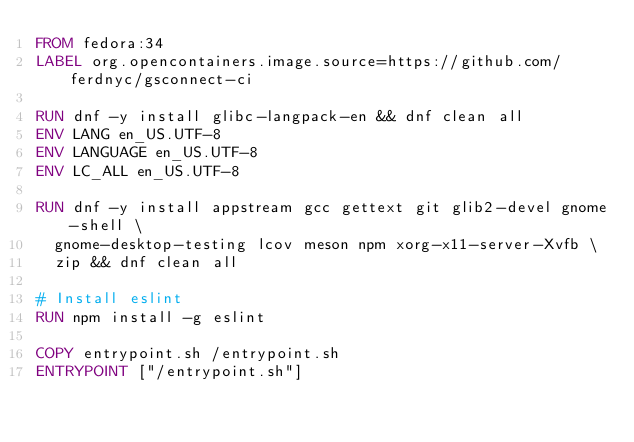<code> <loc_0><loc_0><loc_500><loc_500><_Dockerfile_>FROM fedora:34
LABEL org.opencontainers.image.source=https://github.com/ferdnyc/gsconnect-ci

RUN dnf -y install glibc-langpack-en && dnf clean all
ENV LANG en_US.UTF-8
ENV LANGUAGE en_US.UTF-8
ENV LC_ALL en_US.UTF-8

RUN dnf -y install appstream gcc gettext git glib2-devel gnome-shell \
  gnome-desktop-testing lcov meson npm xorg-x11-server-Xvfb \
  zip && dnf clean all

# Install eslint
RUN npm install -g eslint

COPY entrypoint.sh /entrypoint.sh
ENTRYPOINT ["/entrypoint.sh"]
</code> 